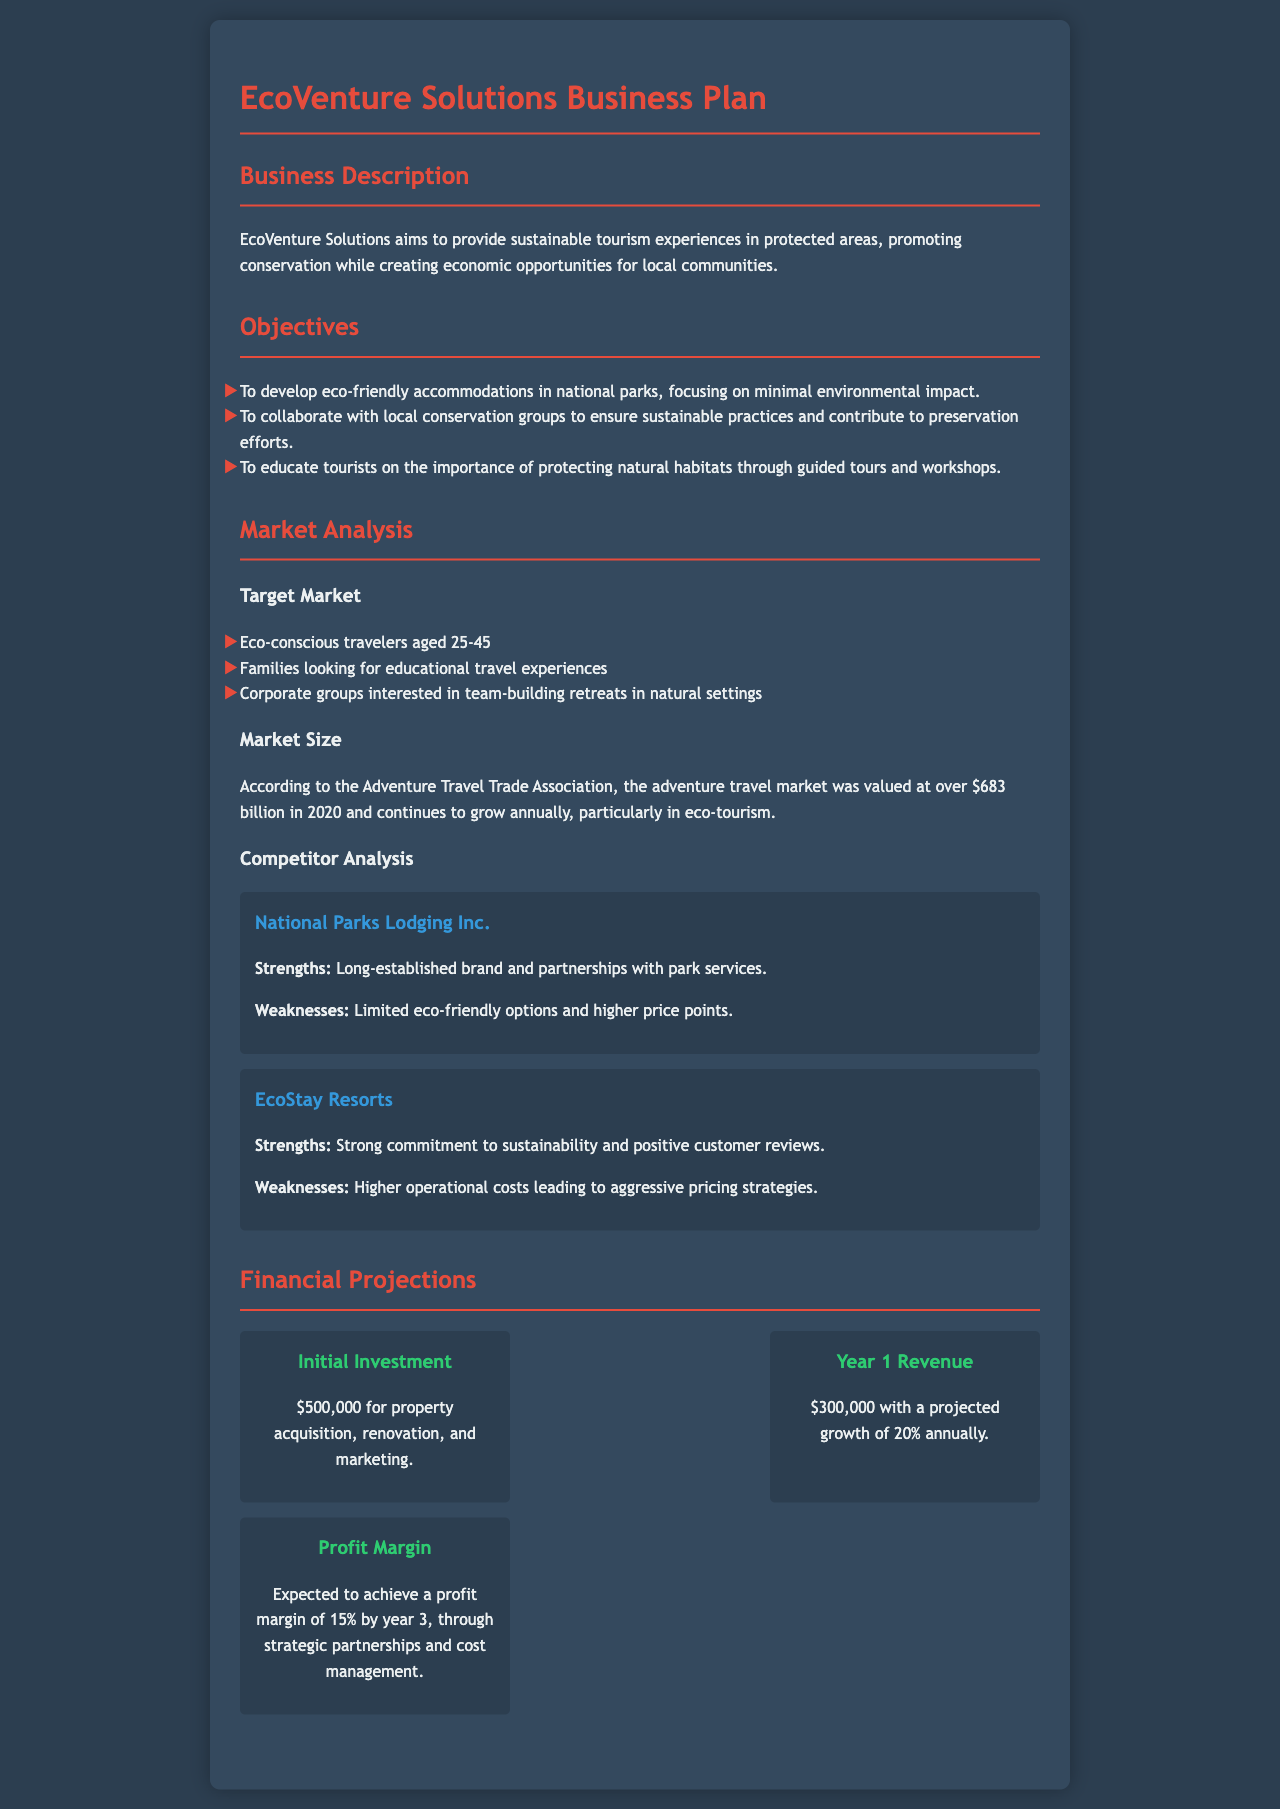what is the business name? The name of the business is stated in the document's title.
Answer: EcoVenture Solutions how much is the initial investment? The initial investment is listed in the financial projections section of the document.
Answer: $500,000 what is the target age group of travelers? The document specifies the target market, including age ranges.
Answer: 25-45 what is the expected profit margin by year 3? The document provides statistical information about profit expectations in the financial section.
Answer: 15% what is the projected revenue for Year 1? The Year 1 revenue is directly mentioned in the financial projections section.
Answer: $300,000 which company has a strong commitment to sustainability? The competitor analysis section lists companies and their strengths.
Answer: EcoStay Resorts what percentage of annual growth is predicted? The document indicates the anticipated growth percentage per year.
Answer: 20% what type of experiences does EcoVenture Solutions aim to provide? The business description outlines the type of experiences offered by EcoVenture Solutions.
Answer: sustainable tourism experiences what is one weakness of National Parks Lodging Inc.? The competitor analysis section includes weaknesses for each competitor.
Answer: higher price points 